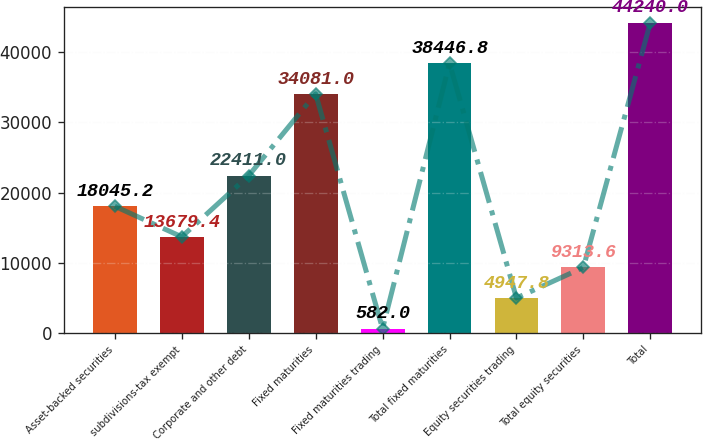<chart> <loc_0><loc_0><loc_500><loc_500><bar_chart><fcel>Asset-backed securities<fcel>subdivisions-tax exempt<fcel>Corporate and other debt<fcel>Fixed maturities<fcel>Fixed maturities trading<fcel>Total fixed maturities<fcel>Equity securities trading<fcel>Total equity securities<fcel>Total<nl><fcel>18045.2<fcel>13679.4<fcel>22411<fcel>34081<fcel>582<fcel>38446.8<fcel>4947.8<fcel>9313.6<fcel>44240<nl></chart> 